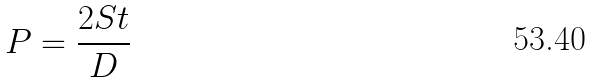<formula> <loc_0><loc_0><loc_500><loc_500>P = \frac { 2 S t } { D }</formula> 